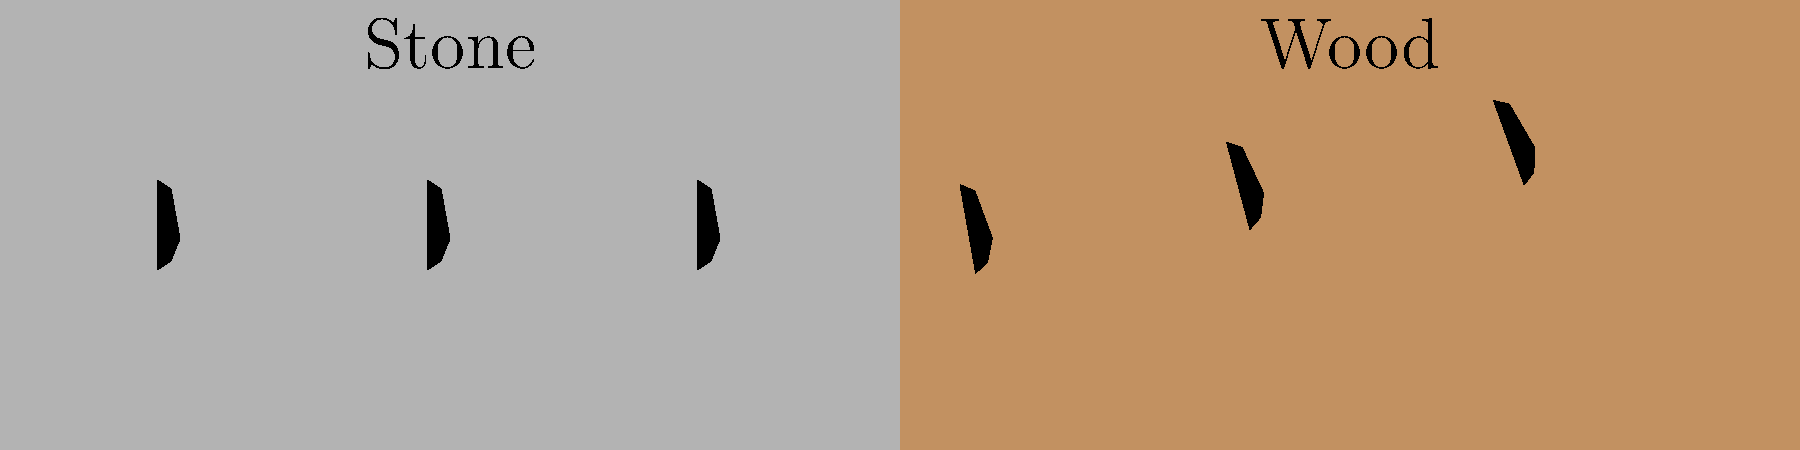As a monastery caretaker, you notice a change in the gait pattern of monks walking from the stone floor to the wooden floor during sacred rituals. Based on the footprint sequence shown, what biomechanical adaptation is most likely occurring, and how might this affect the monks' movement? 1. Observe the footprint pattern:
   - On the stone surface (left), footprints are evenly spaced and aligned.
   - On the wooden surface (right), footprints show increasing angles and spacing.

2. Biomechanical analysis:
   a) Change in step width: The distance between footprints increases on wood.
   b) Change in foot angle: Footprints rotate outward progressively on wood.
   c) Change in step length: The distance between steps increases slightly on wood.

3. Likely causes:
   - Wooden floors often have less friction than stone floors.
   - The transition from a hard (stone) to a slightly softer (wood) surface affects impact absorption.

4. Biomechanical adaptation:
   - Wider stance: Increases base of support for better stability on the potentially slippery wood.
   - Foot rotation: Helps to increase the surface area of contact, improving grip.
   - Longer steps: May indicate a faster walking speed to maintain balance on the less stable surface.

5. Effects on monks' movement:
   - Increased muscle activation in lower limbs to maintain balance.
   - Potential for higher energy expenditure during the transition.
   - Possible changes in the rhythm and solemnity of the ritual procession.

6. Conclusion:
   The monks are likely adapting their gait to maintain stability and balance when transitioning from the stone to the wooden floor. This adaptation involves widening their stance, rotating their feet outward, and potentially increasing their step length.
Answer: Stability adaptation: wider stance, foot rotation, and longer steps for balance on wood 